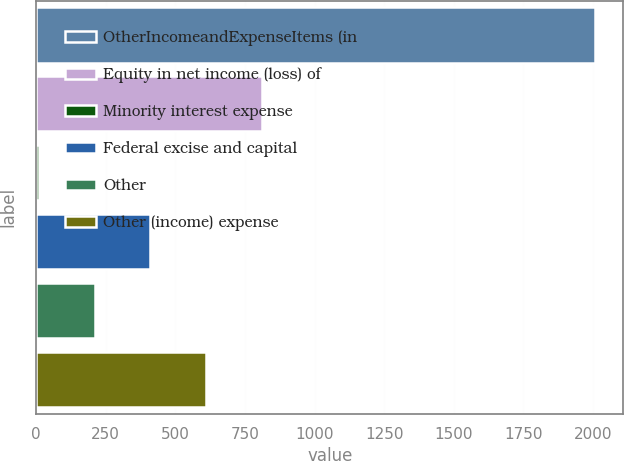Convert chart to OTSL. <chart><loc_0><loc_0><loc_500><loc_500><bar_chart><fcel>OtherIncomeandExpenseItems (in<fcel>Equity in net income (loss) of<fcel>Minority interest expense<fcel>Federal excise and capital<fcel>Other<fcel>Other (income) expense<nl><fcel>2008<fcel>809.8<fcel>11<fcel>410.4<fcel>210.7<fcel>610.1<nl></chart> 